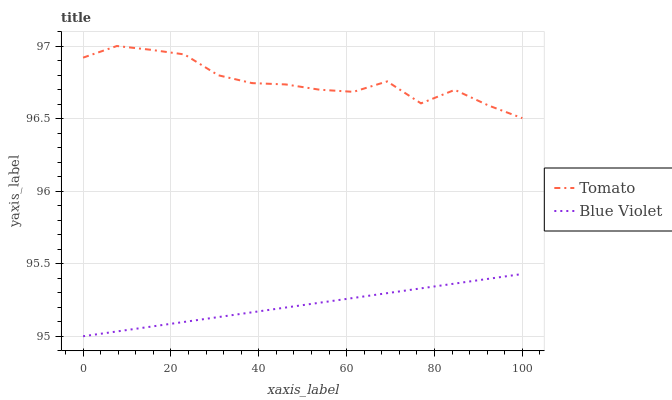Does Blue Violet have the minimum area under the curve?
Answer yes or no. Yes. Does Tomato have the maximum area under the curve?
Answer yes or no. Yes. Does Blue Violet have the maximum area under the curve?
Answer yes or no. No. Is Blue Violet the smoothest?
Answer yes or no. Yes. Is Tomato the roughest?
Answer yes or no. Yes. Is Blue Violet the roughest?
Answer yes or no. No. Does Blue Violet have the lowest value?
Answer yes or no. Yes. Does Tomato have the highest value?
Answer yes or no. Yes. Does Blue Violet have the highest value?
Answer yes or no. No. Is Blue Violet less than Tomato?
Answer yes or no. Yes. Is Tomato greater than Blue Violet?
Answer yes or no. Yes. Does Blue Violet intersect Tomato?
Answer yes or no. No. 